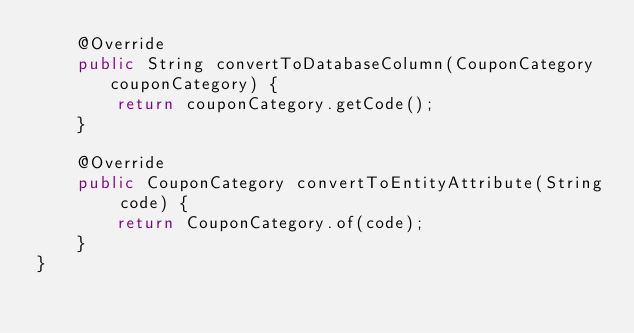Convert code to text. <code><loc_0><loc_0><loc_500><loc_500><_Java_>    @Override
    public String convertToDatabaseColumn(CouponCategory couponCategory) {
        return couponCategory.getCode();
    }

    @Override
    public CouponCategory convertToEntityAttribute(String code) {
        return CouponCategory.of(code);
    }
}
</code> 